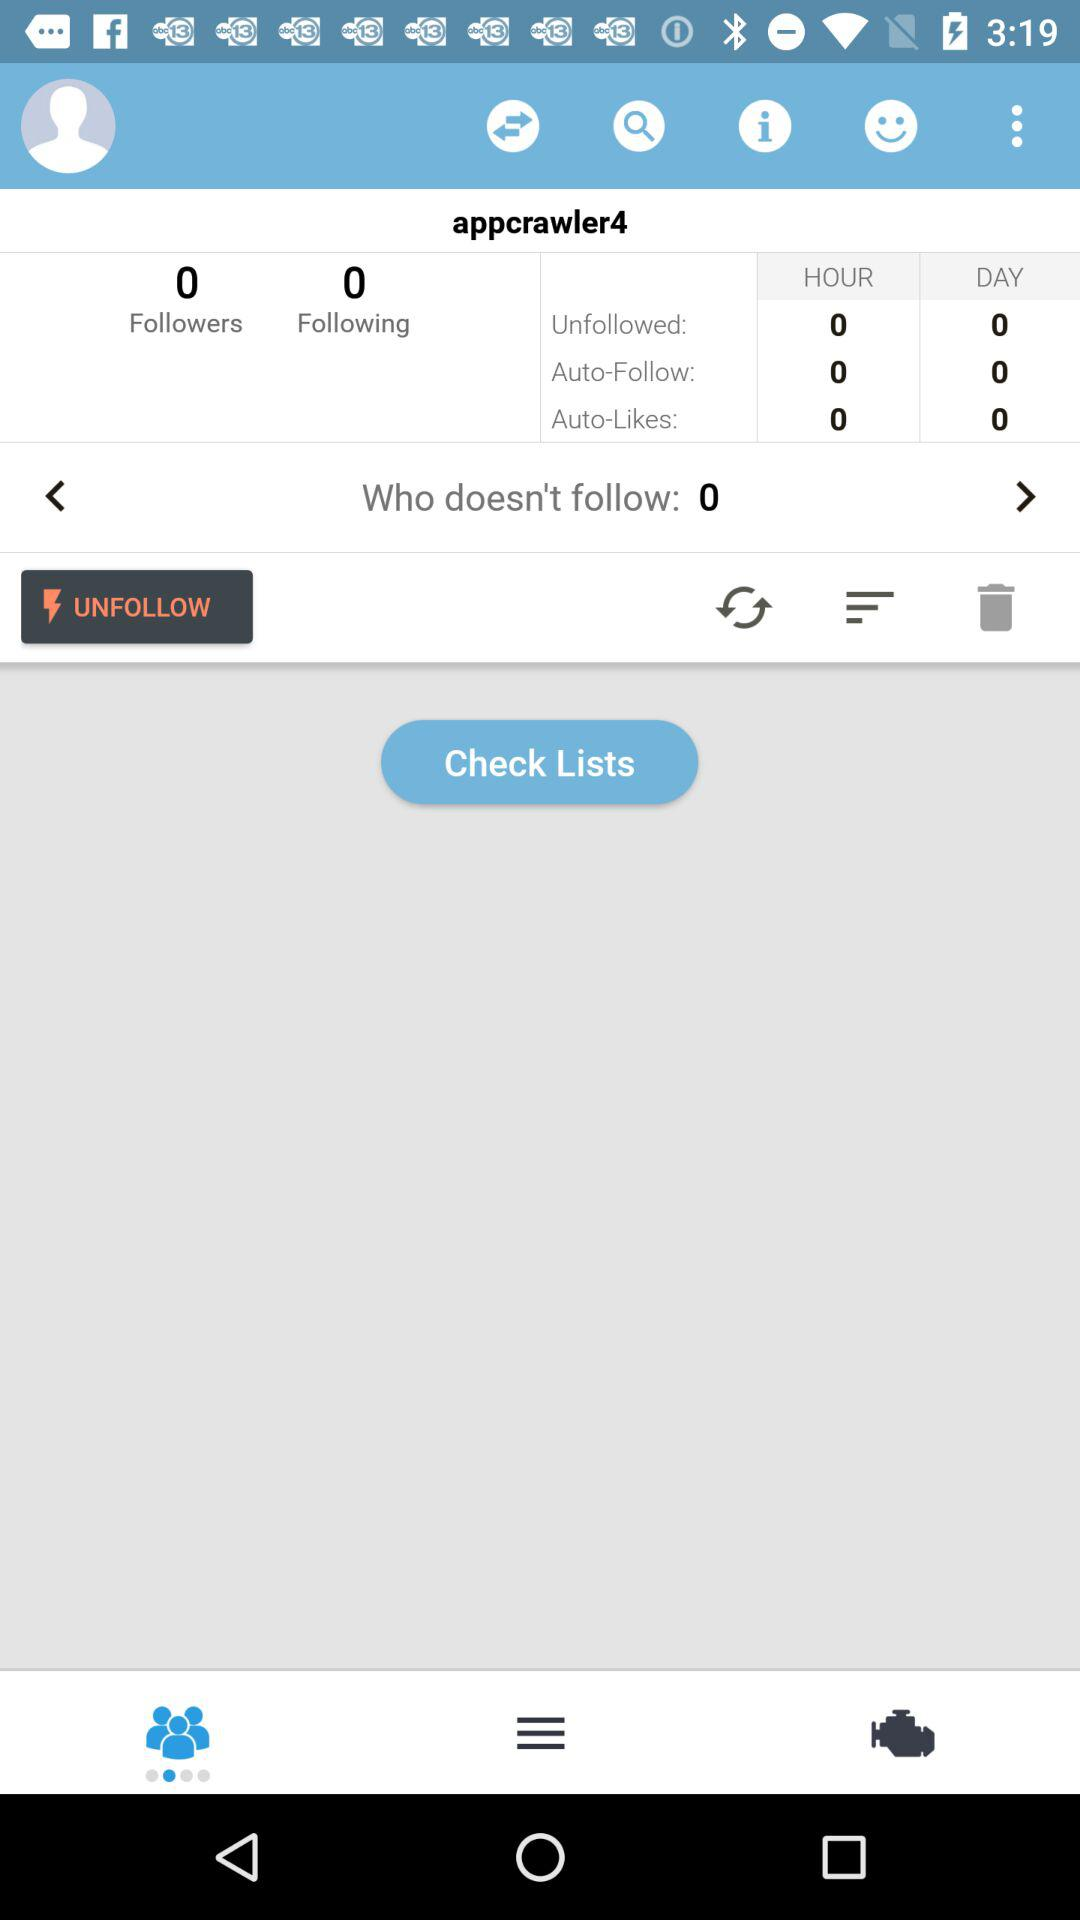How many people have unfollowed "appcrawler4" in a day? The number of people who have unfollowed "appcrawler4" in a day is 0. 